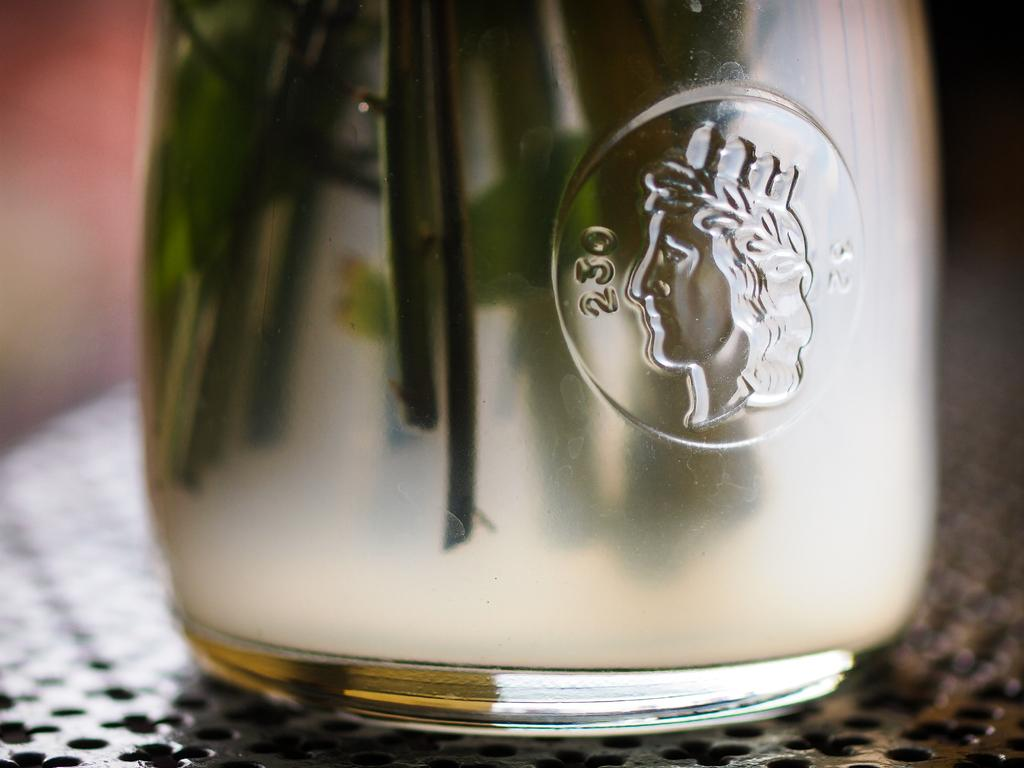What object can be seen in the image? There is a bottle in the image. Where is the bottle located? The bottle is on a table. Is there any text or number on the bottle? Yes, there is a number written on the bottle. What else is inside the bottle? There is a photo of a lady drawn inside the bottle. What type of bread is being used as a treatment for the lady in the image? There is no bread or treatment for the lady in the image; it only features a bottle with a photo of a lady drawn inside. 